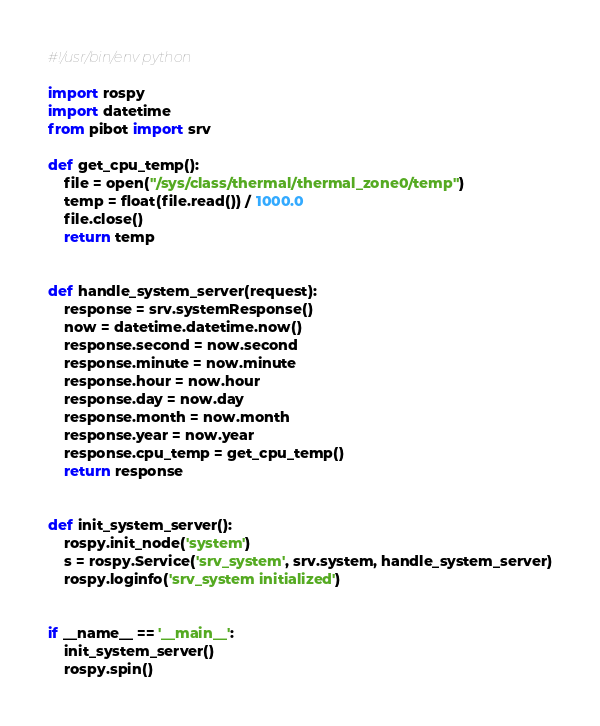Convert code to text. <code><loc_0><loc_0><loc_500><loc_500><_Python_>#!/usr/bin/env python

import rospy
import datetime
from pibot import srv

def get_cpu_temp():
    file = open("/sys/class/thermal/thermal_zone0/temp")
    temp = float(file.read()) / 1000.0
    file.close()
    return temp


def handle_system_server(request):
    response = srv.systemResponse()
    now = datetime.datetime.now()
    response.second = now.second
    response.minute = now.minute
    response.hour = now.hour
    response.day = now.day
    response.month = now.month
    response.year = now.year
    response.cpu_temp = get_cpu_temp()
    return response


def init_system_server():
    rospy.init_node('system')
    s = rospy.Service('srv_system', srv.system, handle_system_server)
    rospy.loginfo('srv_system initialized')


if __name__ == '__main__':
    init_system_server()
    rospy.spin()

</code> 